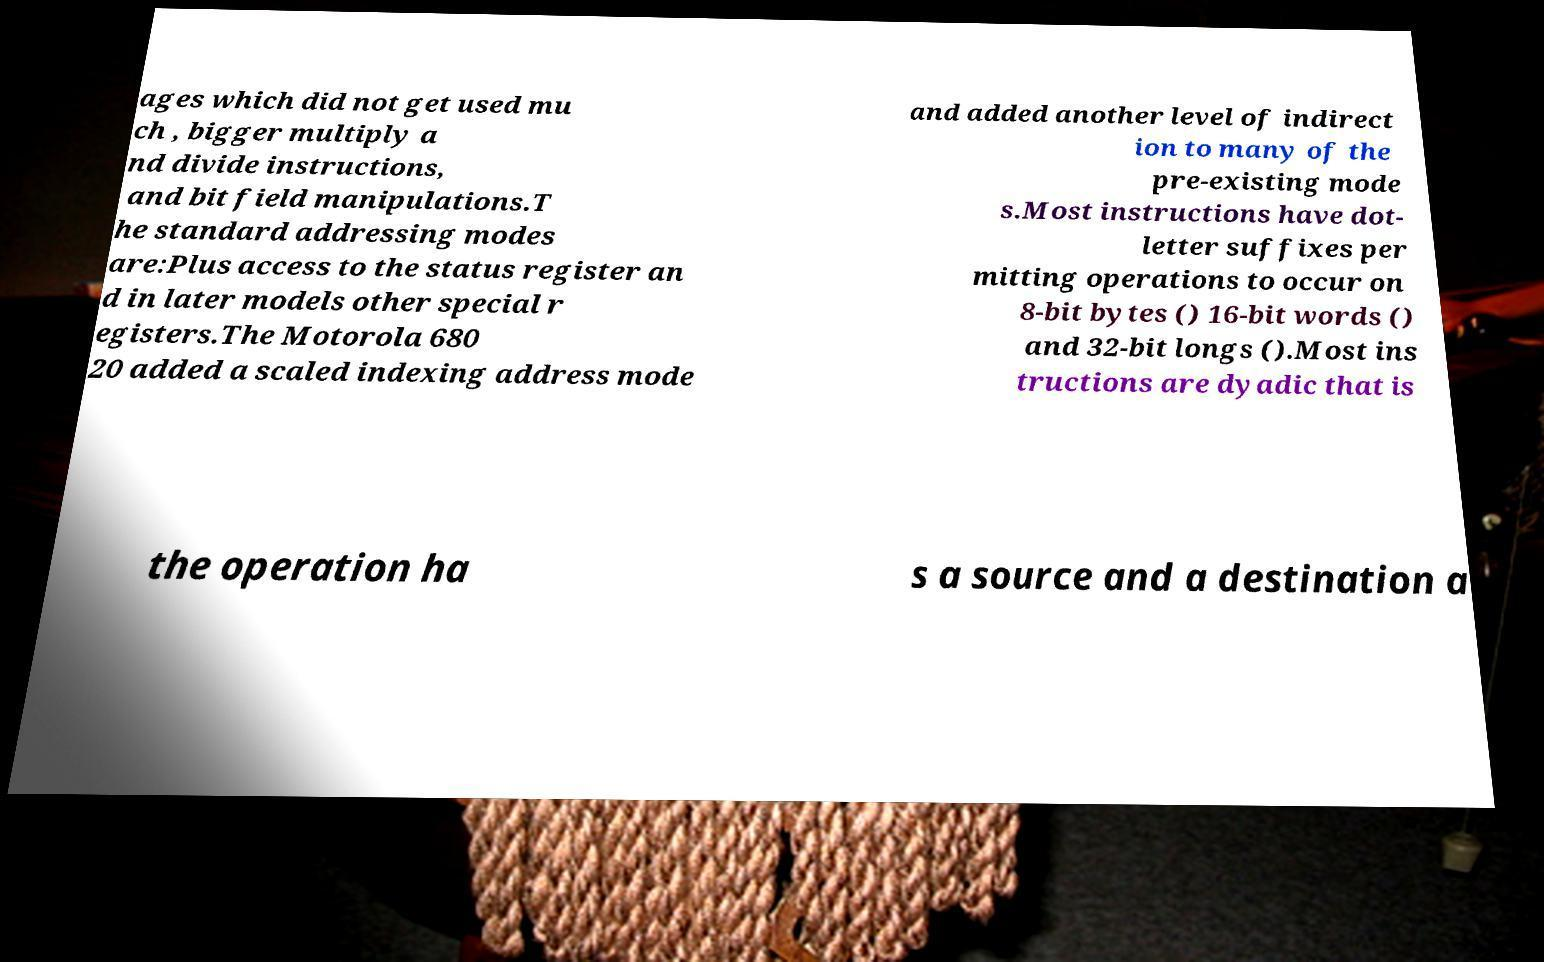What messages or text are displayed in this image? I need them in a readable, typed format. ages which did not get used mu ch , bigger multiply a nd divide instructions, and bit field manipulations.T he standard addressing modes are:Plus access to the status register an d in later models other special r egisters.The Motorola 680 20 added a scaled indexing address mode and added another level of indirect ion to many of the pre-existing mode s.Most instructions have dot- letter suffixes per mitting operations to occur on 8-bit bytes () 16-bit words () and 32-bit longs ().Most ins tructions are dyadic that is the operation ha s a source and a destination a 